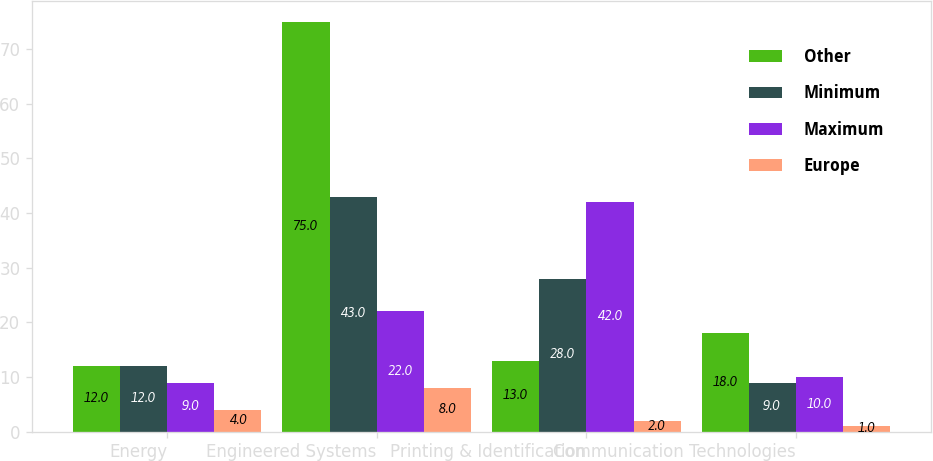Convert chart to OTSL. <chart><loc_0><loc_0><loc_500><loc_500><stacked_bar_chart><ecel><fcel>Energy<fcel>Engineered Systems<fcel>Printing & Identification<fcel>Communication Technologies<nl><fcel>Other<fcel>12<fcel>75<fcel>13<fcel>18<nl><fcel>Minimum<fcel>12<fcel>43<fcel>28<fcel>9<nl><fcel>Maximum<fcel>9<fcel>22<fcel>42<fcel>10<nl><fcel>Europe<fcel>4<fcel>8<fcel>2<fcel>1<nl></chart> 